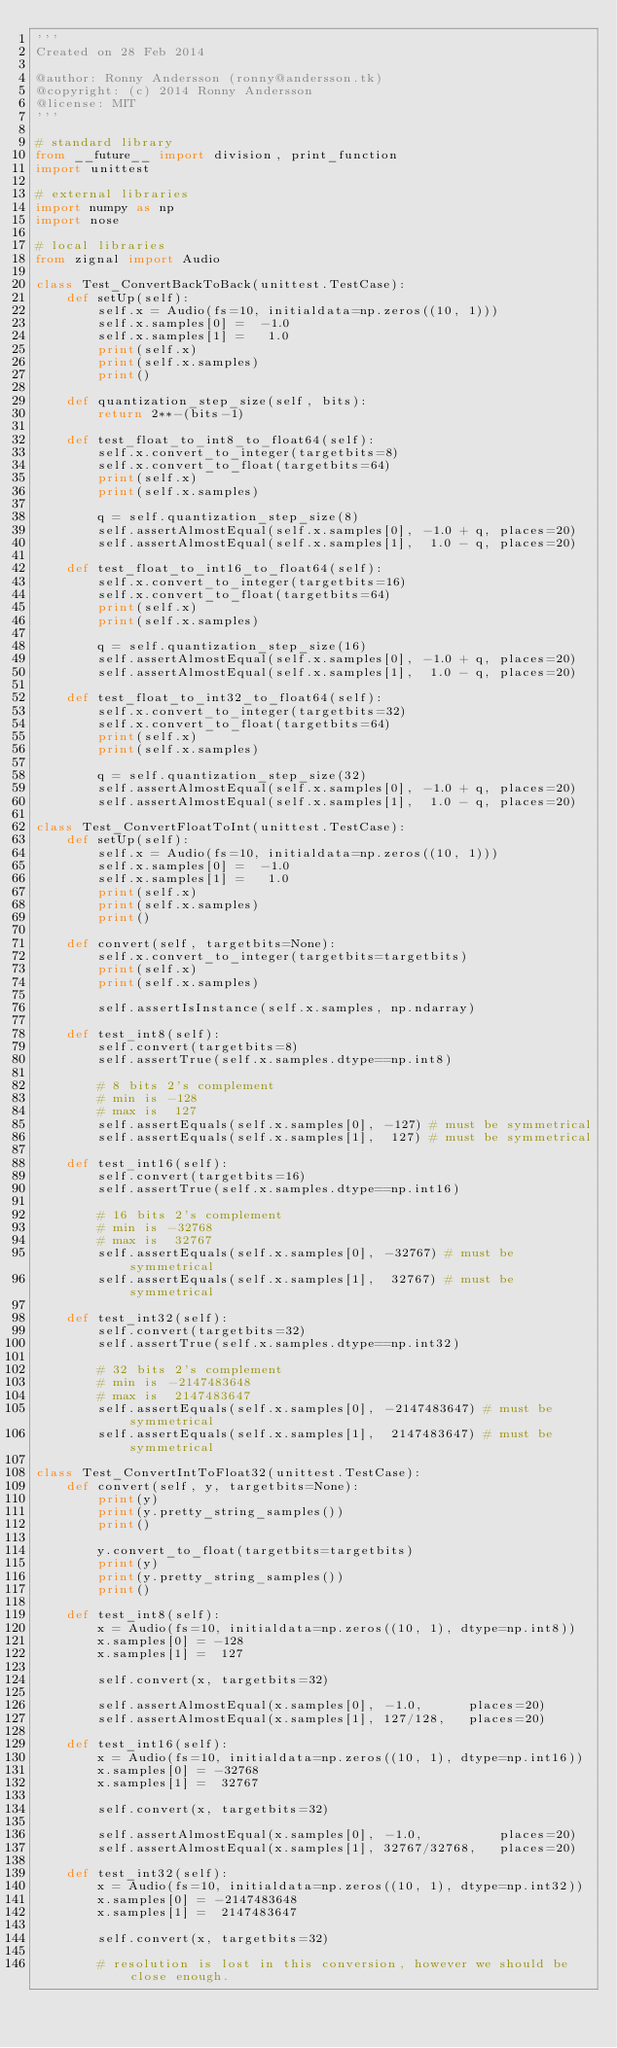Convert code to text. <code><loc_0><loc_0><loc_500><loc_500><_Python_>'''
Created on 28 Feb 2014

@author: Ronny Andersson (ronny@andersson.tk)
@copyright: (c) 2014 Ronny Andersson
@license: MIT
'''

# standard library
from __future__ import division, print_function
import unittest

# external libraries
import numpy as np
import nose

# local libraries
from zignal import Audio

class Test_ConvertBackToBack(unittest.TestCase):
    def setUp(self):
        self.x = Audio(fs=10, initialdata=np.zeros((10, 1)))
        self.x.samples[0] =  -1.0
        self.x.samples[1] =   1.0
        print(self.x)
        print(self.x.samples)
        print()

    def quantization_step_size(self, bits):
        return 2**-(bits-1)

    def test_float_to_int8_to_float64(self):
        self.x.convert_to_integer(targetbits=8)
        self.x.convert_to_float(targetbits=64)
        print(self.x)
        print(self.x.samples)

        q = self.quantization_step_size(8)
        self.assertAlmostEqual(self.x.samples[0], -1.0 + q, places=20)
        self.assertAlmostEqual(self.x.samples[1],  1.0 - q, places=20)

    def test_float_to_int16_to_float64(self):
        self.x.convert_to_integer(targetbits=16)
        self.x.convert_to_float(targetbits=64)
        print(self.x)
        print(self.x.samples)

        q = self.quantization_step_size(16)
        self.assertAlmostEqual(self.x.samples[0], -1.0 + q, places=20)
        self.assertAlmostEqual(self.x.samples[1],  1.0 - q, places=20)

    def test_float_to_int32_to_float64(self):
        self.x.convert_to_integer(targetbits=32)
        self.x.convert_to_float(targetbits=64)
        print(self.x)
        print(self.x.samples)

        q = self.quantization_step_size(32)
        self.assertAlmostEqual(self.x.samples[0], -1.0 + q, places=20)
        self.assertAlmostEqual(self.x.samples[1],  1.0 - q, places=20)

class Test_ConvertFloatToInt(unittest.TestCase):
    def setUp(self):
        self.x = Audio(fs=10, initialdata=np.zeros((10, 1)))
        self.x.samples[0] =  -1.0
        self.x.samples[1] =   1.0
        print(self.x)
        print(self.x.samples)
        print()

    def convert(self, targetbits=None):
        self.x.convert_to_integer(targetbits=targetbits)
        print(self.x)
        print(self.x.samples)

        self.assertIsInstance(self.x.samples, np.ndarray)

    def test_int8(self):
        self.convert(targetbits=8)
        self.assertTrue(self.x.samples.dtype==np.int8)

        # 8 bits 2's complement
        # min is -128
        # max is  127
        self.assertEquals(self.x.samples[0], -127) # must be symmetrical
        self.assertEquals(self.x.samples[1],  127) # must be symmetrical

    def test_int16(self):
        self.convert(targetbits=16)
        self.assertTrue(self.x.samples.dtype==np.int16)

        # 16 bits 2's complement
        # min is -32768
        # max is  32767
        self.assertEquals(self.x.samples[0], -32767) # must be symmetrical
        self.assertEquals(self.x.samples[1],  32767) # must be symmetrical

    def test_int32(self):
        self.convert(targetbits=32)
        self.assertTrue(self.x.samples.dtype==np.int32)

        # 32 bits 2's complement
        # min is -2147483648
        # max is  2147483647
        self.assertEquals(self.x.samples[0], -2147483647) # must be symmetrical
        self.assertEquals(self.x.samples[1],  2147483647) # must be symmetrical

class Test_ConvertIntToFloat32(unittest.TestCase):
    def convert(self, y, targetbits=None):
        print(y)
        print(y.pretty_string_samples())
        print()

        y.convert_to_float(targetbits=targetbits)
        print(y)
        print(y.pretty_string_samples())
        print()

    def test_int8(self):
        x = Audio(fs=10, initialdata=np.zeros((10, 1), dtype=np.int8))
        x.samples[0] = -128
        x.samples[1] =  127

        self.convert(x, targetbits=32)

        self.assertAlmostEqual(x.samples[0], -1.0,      places=20)
        self.assertAlmostEqual(x.samples[1], 127/128,   places=20)

    def test_int16(self):
        x = Audio(fs=10, initialdata=np.zeros((10, 1), dtype=np.int16))
        x.samples[0] = -32768
        x.samples[1] =  32767

        self.convert(x, targetbits=32)

        self.assertAlmostEqual(x.samples[0], -1.0,          places=20)
        self.assertAlmostEqual(x.samples[1], 32767/32768,   places=20)

    def test_int32(self):
        x = Audio(fs=10, initialdata=np.zeros((10, 1), dtype=np.int32))
        x.samples[0] = -2147483648
        x.samples[1] =  2147483647

        self.convert(x, targetbits=32)

        # resolution is lost in this conversion, however we should be close enough.</code> 